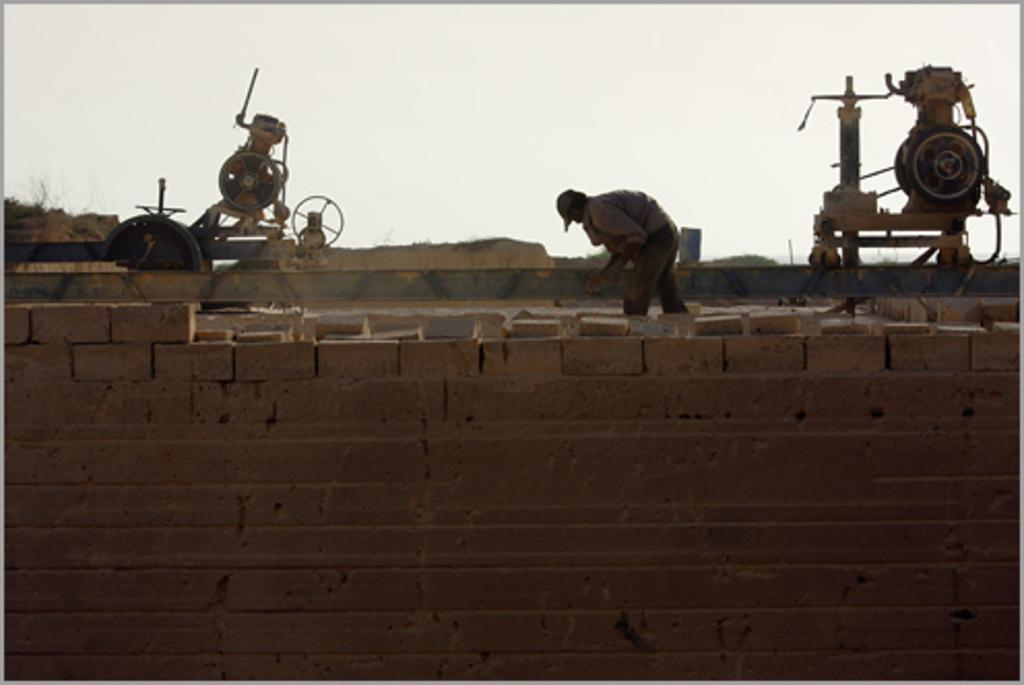What is present on the wall in the image? There are two machines on the wall in the image. Can you describe the man in the image? There is a man in the image, but no specific details about his appearance or actions are provided. What is the purpose of the machines on the wall? The purpose of the machines on the wall is not specified in the provided facts. What type of celery is the man eating in the image? There is no celery present in the image. Where is the school located in the image? There is no school present in the image. 